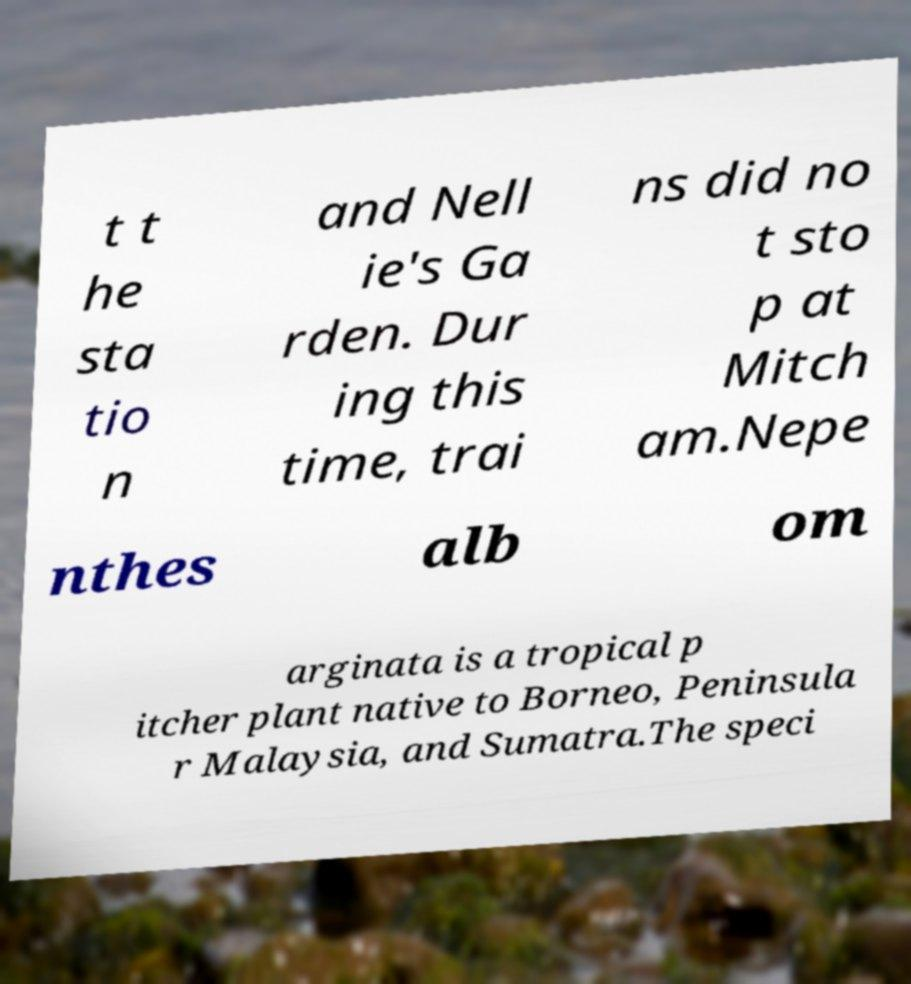For documentation purposes, I need the text within this image transcribed. Could you provide that? t t he sta tio n and Nell ie's Ga rden. Dur ing this time, trai ns did no t sto p at Mitch am.Nepe nthes alb om arginata is a tropical p itcher plant native to Borneo, Peninsula r Malaysia, and Sumatra.The speci 